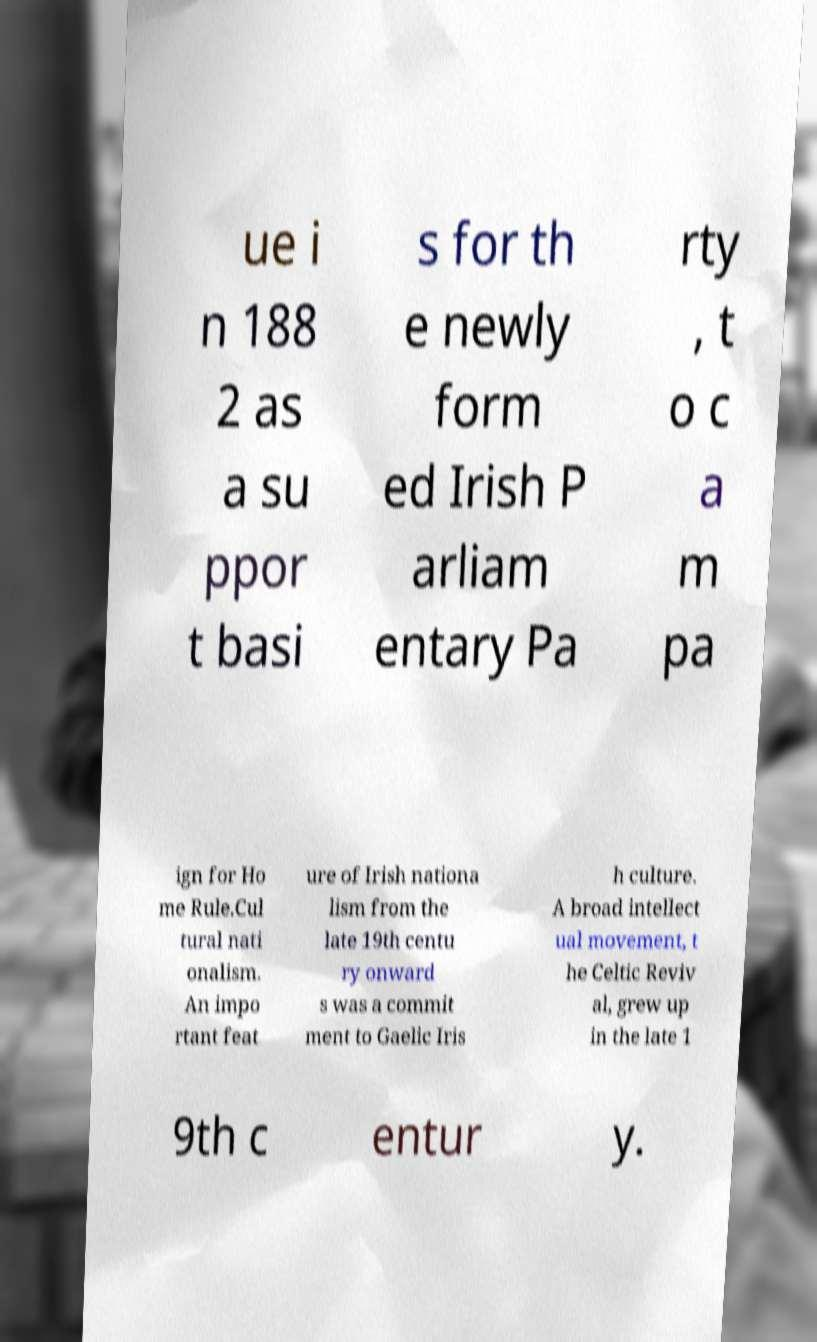What messages or text are displayed in this image? I need them in a readable, typed format. ue i n 188 2 as a su ppor t basi s for th e newly form ed Irish P arliam entary Pa rty , t o c a m pa ign for Ho me Rule.Cul tural nati onalism. An impo rtant feat ure of Irish nationa lism from the late 19th centu ry onward s was a commit ment to Gaelic Iris h culture. A broad intellect ual movement, t he Celtic Reviv al, grew up in the late 1 9th c entur y. 